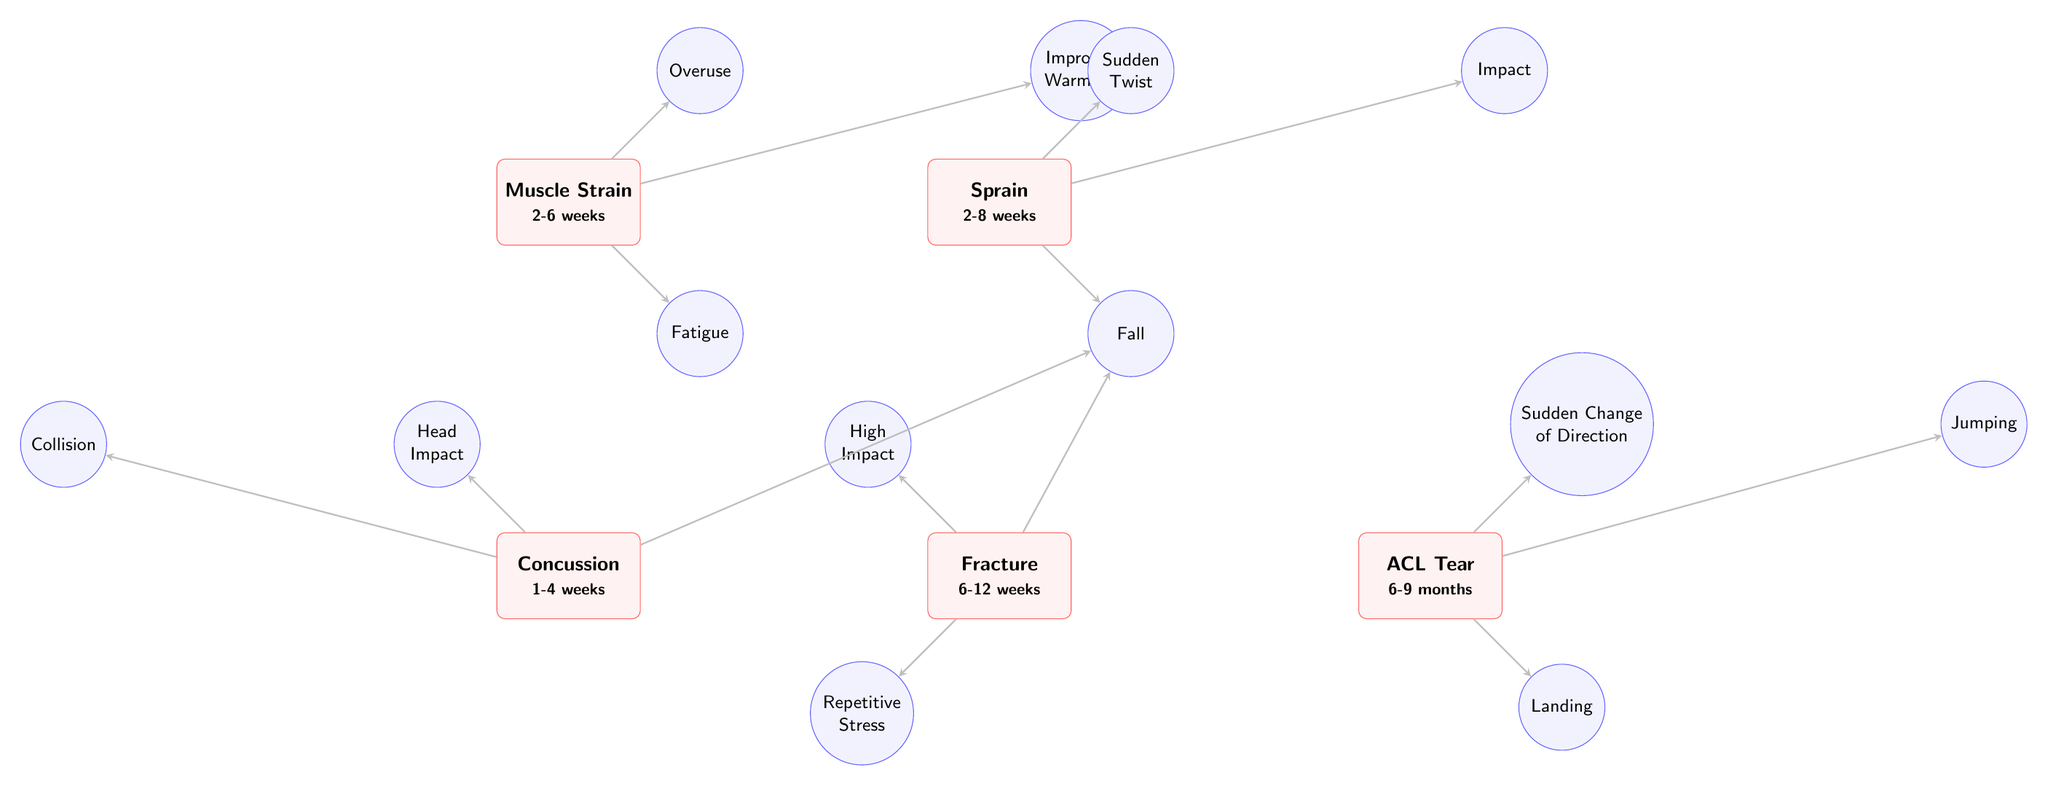What are the types of injuries shown in the diagram? The diagram shows five types of injuries which are displayed as rectangular nodes. These injuries are Muscle Strain, Sprain, Concussion, Fracture, and ACL Tear.
Answer: Muscle Strain, Sprain, Concussion, Fracture, ACL Tear Which injury has the longest recovery time? To determine the longest recovery time, compare the recovery times listed under each injury type. The ACL Tear has a recovery time of 6-9 months, which is longer than the others.
Answer: ACL Tear How many causes are linked to the Sprain injury? The Sprain injury has three causes linked to it: Sudden Twist, Impact, and Fall. This can be counted from the arrows directed towards the Sprain node.
Answer: 3 What is the recovery time for a Fracture? The Fracture injury node states that the recovery time is 6-12 weeks, directly visible in the node itself.
Answer: 6-12 weeks Which injury is associated with High Impact as a cause? The High Impact cause is linked to the Fracture injury by an arrow, indicating it is a cause leading to that specific injury.
Answer: Fracture What recovery time is indicated for Concussion? The recovery time for Concussion is stated as 1-4 weeks within the diagram, directly visible in the Concussion node.
Answer: 1-4 weeks What is a common cause for both Muscle Strain and Sprain? The cause of Fatigue causes both Muscle Strain and Sprain; checking the arrows shows that Fatigue points to Muscle Strain. However, it only indirectly relates to Sprain, as it causes slight ambiguity. Only focusing on directly indicated links, no direct common cause exists among displayed causes. Therefore, the answer is none.
Answer: None Which injury is directly caused by Landing? The Landing cause is connected to the ACL Tear as shown by the arrow pointing to that specific injury, making it easy to identify the linkage.
Answer: ACL Tear 